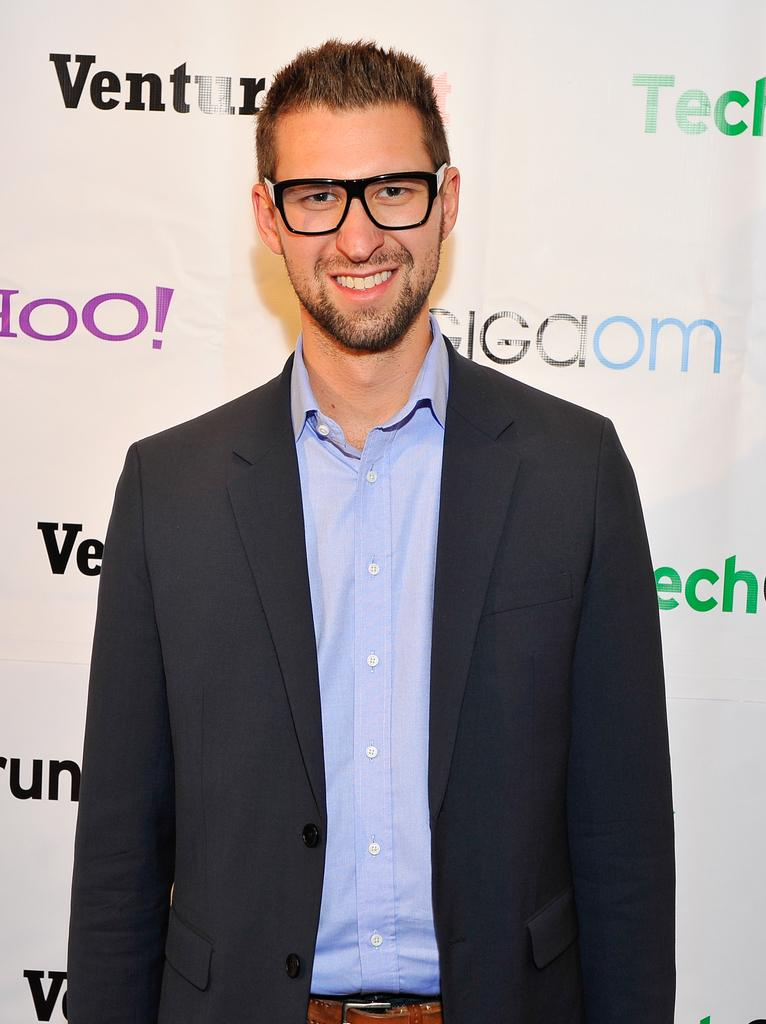Who is present in the image? There is a man in the image. What type of clothing is the man wearing? The man is wearing a shirt, a blazer, and trousers. What is the man standing near in the image? The man is standing near a banner. What type of cakes can be seen on the man's voyage in the image? There is no mention of cakes or a voyage in the image; it simply features a man standing near a banner. 